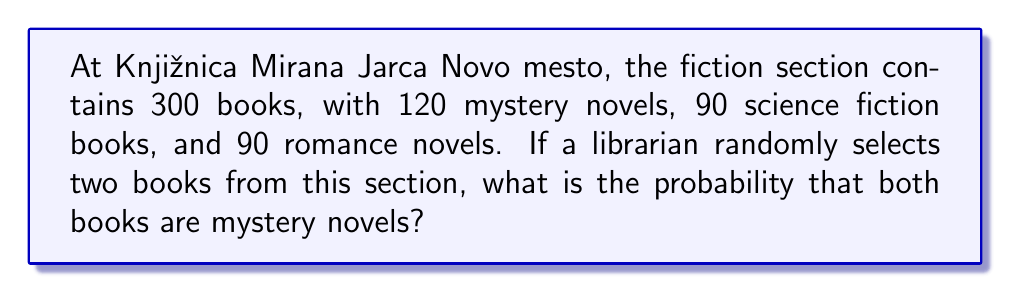Give your solution to this math problem. Let's approach this step-by-step:

1) First, we need to calculate the probability of selecting a mystery novel on the first draw:
   $$P(\text{first book is mystery}) = \frac{120}{300} = \frac{2}{5}$$

2) After selecting the first book, there are now 299 books left, of which 119 are mystery novels (assuming the first book was a mystery novel):
   $$P(\text{second book is mystery | first book was mystery}) = \frac{119}{299}$$

3) The probability of both events occurring is the product of their individual probabilities:
   $$P(\text{both books are mystery}) = P(\text{first book is mystery}) \times P(\text{second book is mystery | first book was mystery})$$

4) Substituting the values:
   $$P(\text{both books are mystery}) = \frac{2}{5} \times \frac{119}{299}$$

5) Simplifying:
   $$P(\text{both books are mystery}) = \frac{238}{1495} \approx 0.1591$$
Answer: $\frac{238}{1495}$ 